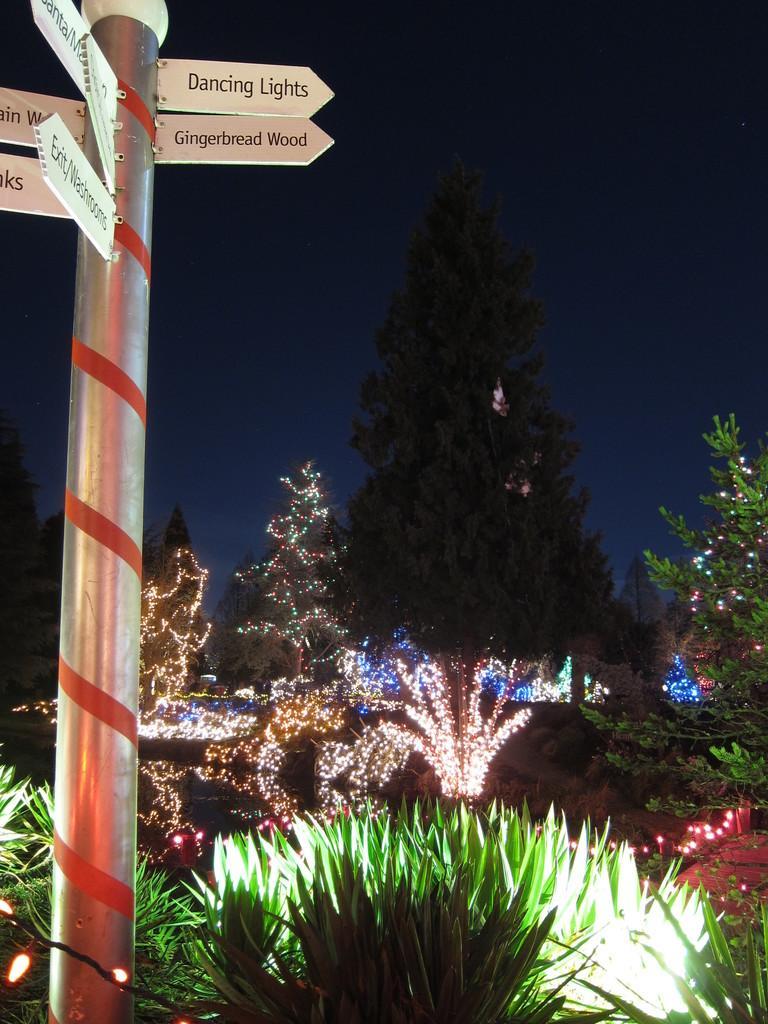Please provide a concise description of this image. Here we can see a pole and there are some name boards attached to it. In the background there are plants and decorative lights to the trees and this is sky. 